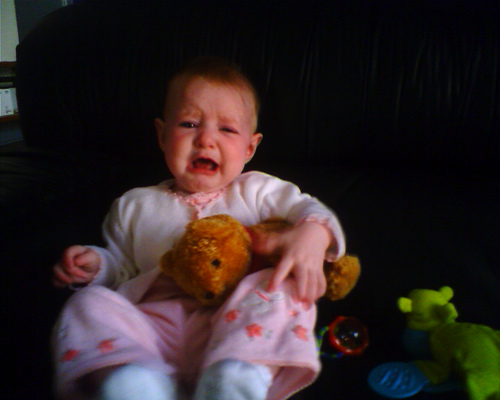Why might the little girl be upset? The little girl's facial expression and posture suggest she might be feeling uncomfortable or distressed, potentially due to hunger, a need for sleep, or simply a moment of upset as often occurs with infants. Her spread fingers and the way she clutches her teddy bear might also indicate a need for comfort. 